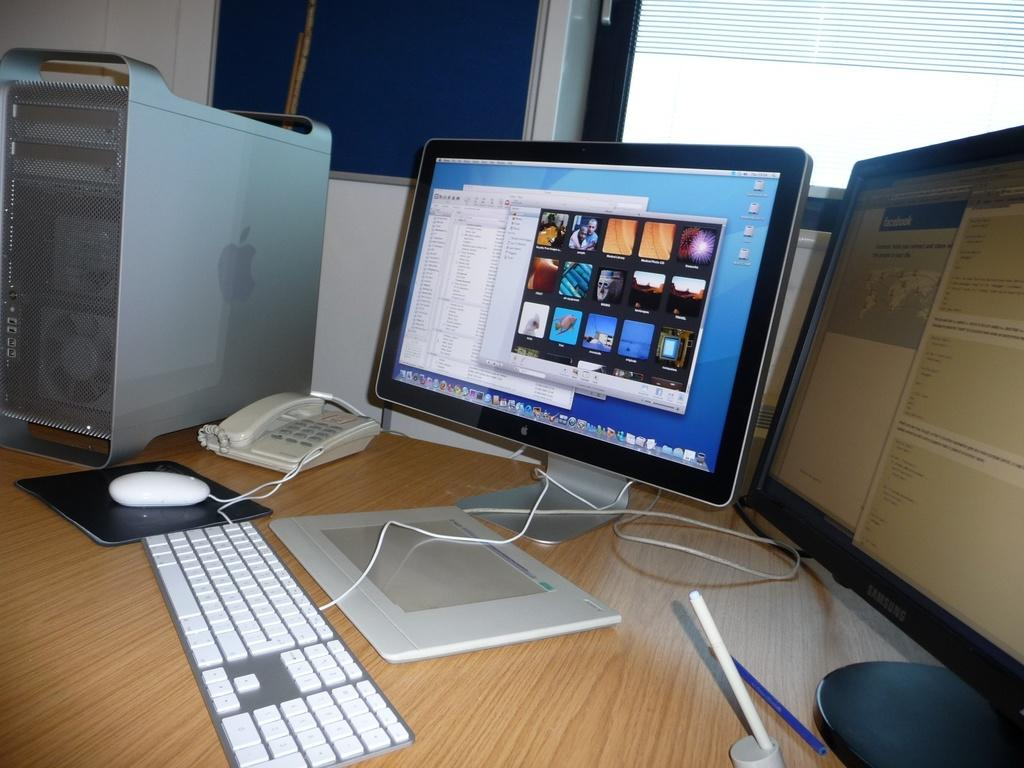What type of electronic device is visible in the image? There is a monitor in the image. What other computer peripherals can be seen in the image? There is a keyboard, a mouse, and a CPU in the image. What additional object is present on the table in the image? There is a telephone in the image. Where are all these objects located in the image? All of these objects are on a table. How many lizards are crawling on the monitor in the image? There are no lizards present in the image. Can you describe the boy sitting next to the table in the image? There is no boy present in the image. 